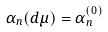<formula> <loc_0><loc_0><loc_500><loc_500>\alpha _ { n } ( d \mu ) = \alpha _ { n } ^ { ( 0 ) }</formula> 